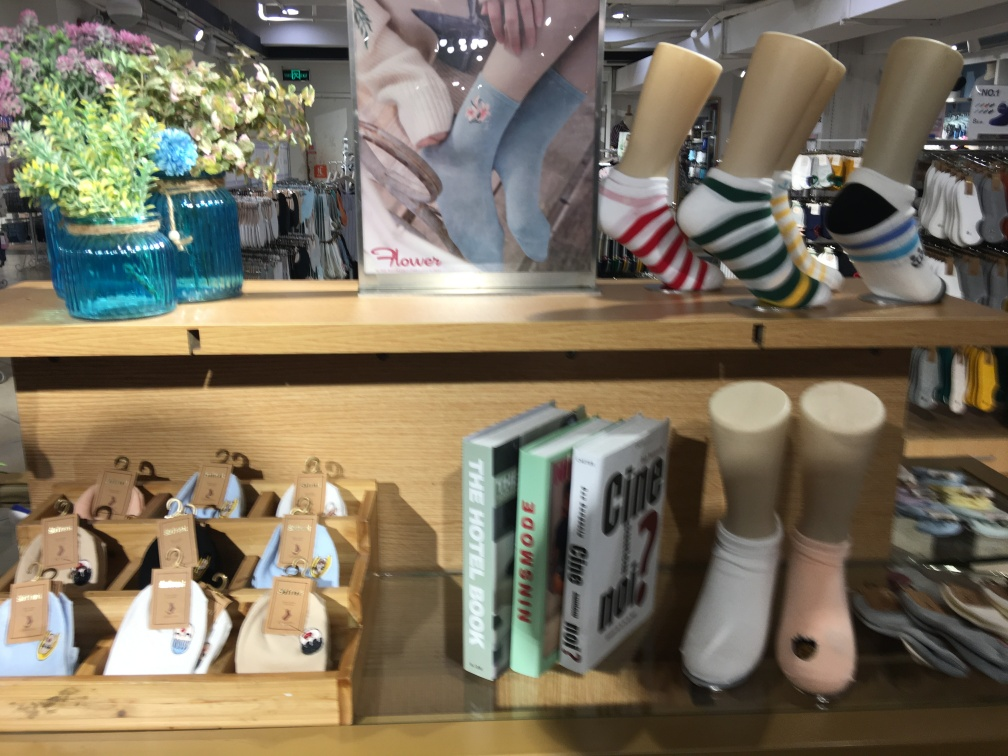Is there a clear background in the image? The background in the image is not entirely clear; it consists of various retail items on display, such as books, flower vases, socks, and shoe forms. The diverse selection of items creates a somewhat cluttered backdrop rather than a clear one. 